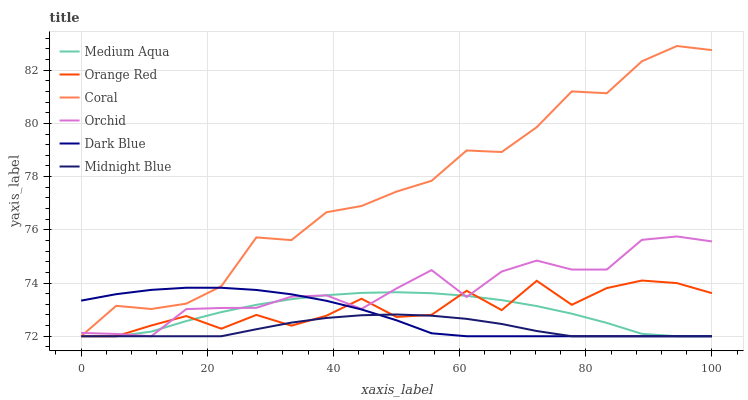Does Dark Blue have the minimum area under the curve?
Answer yes or no. No. Does Dark Blue have the maximum area under the curve?
Answer yes or no. No. Is Coral the smoothest?
Answer yes or no. No. Is Coral the roughest?
Answer yes or no. No. Does Dark Blue have the highest value?
Answer yes or no. No. 